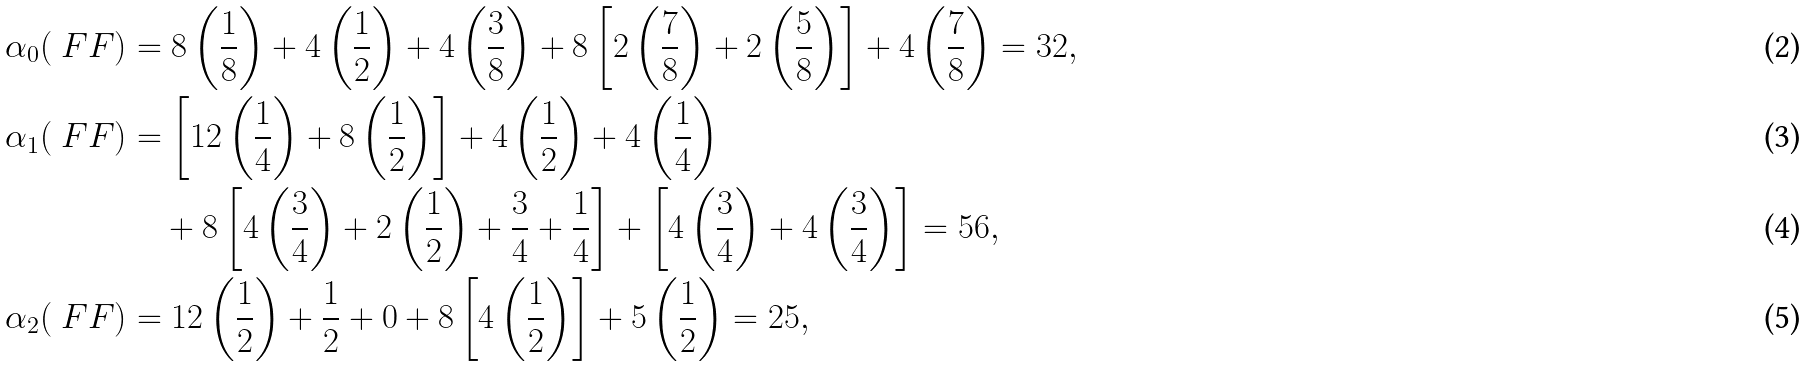<formula> <loc_0><loc_0><loc_500><loc_500>\alpha _ { 0 } ( \ F F ) & = 8 \left ( \frac { 1 } { 8 } \right ) + 4 \left ( \frac { 1 } { 2 } \right ) + 4 \left ( \frac { 3 } { 8 } \right ) + 8 \left [ 2 \left ( \frac { 7 } { 8 } \right ) + 2 \left ( \frac { 5 } { 8 } \right ) \right ] + 4 \left ( \frac { 7 } { 8 } \right ) = 3 2 , \\ \alpha _ { 1 } ( \ F F ) & = \left [ 1 2 \left ( \frac { 1 } { 4 } \right ) + 8 \left ( \frac { 1 } { 2 } \right ) \right ] + 4 \left ( \frac { 1 } { 2 } \right ) + 4 \left ( \frac { 1 } { 4 } \right ) \\ & \quad + 8 \left [ 4 \left ( \frac { 3 } { 4 } \right ) + 2 \left ( \frac { 1 } { 2 } \right ) + \frac { 3 } { 4 } + \frac { 1 } { 4 } \right ] + \left [ 4 \left ( \frac { 3 } { 4 } \right ) + 4 \left ( \frac { 3 } { 4 } \right ) \right ] = 5 6 , \\ \alpha _ { 2 } ( \ F F ) & = 1 2 \left ( \frac { 1 } { 2 } \right ) + \frac { 1 } { 2 } + 0 + 8 \left [ 4 \left ( \frac { 1 } { 2 } \right ) \right ] + 5 \left ( \frac { 1 } { 2 } \right ) = 2 5 ,</formula> 